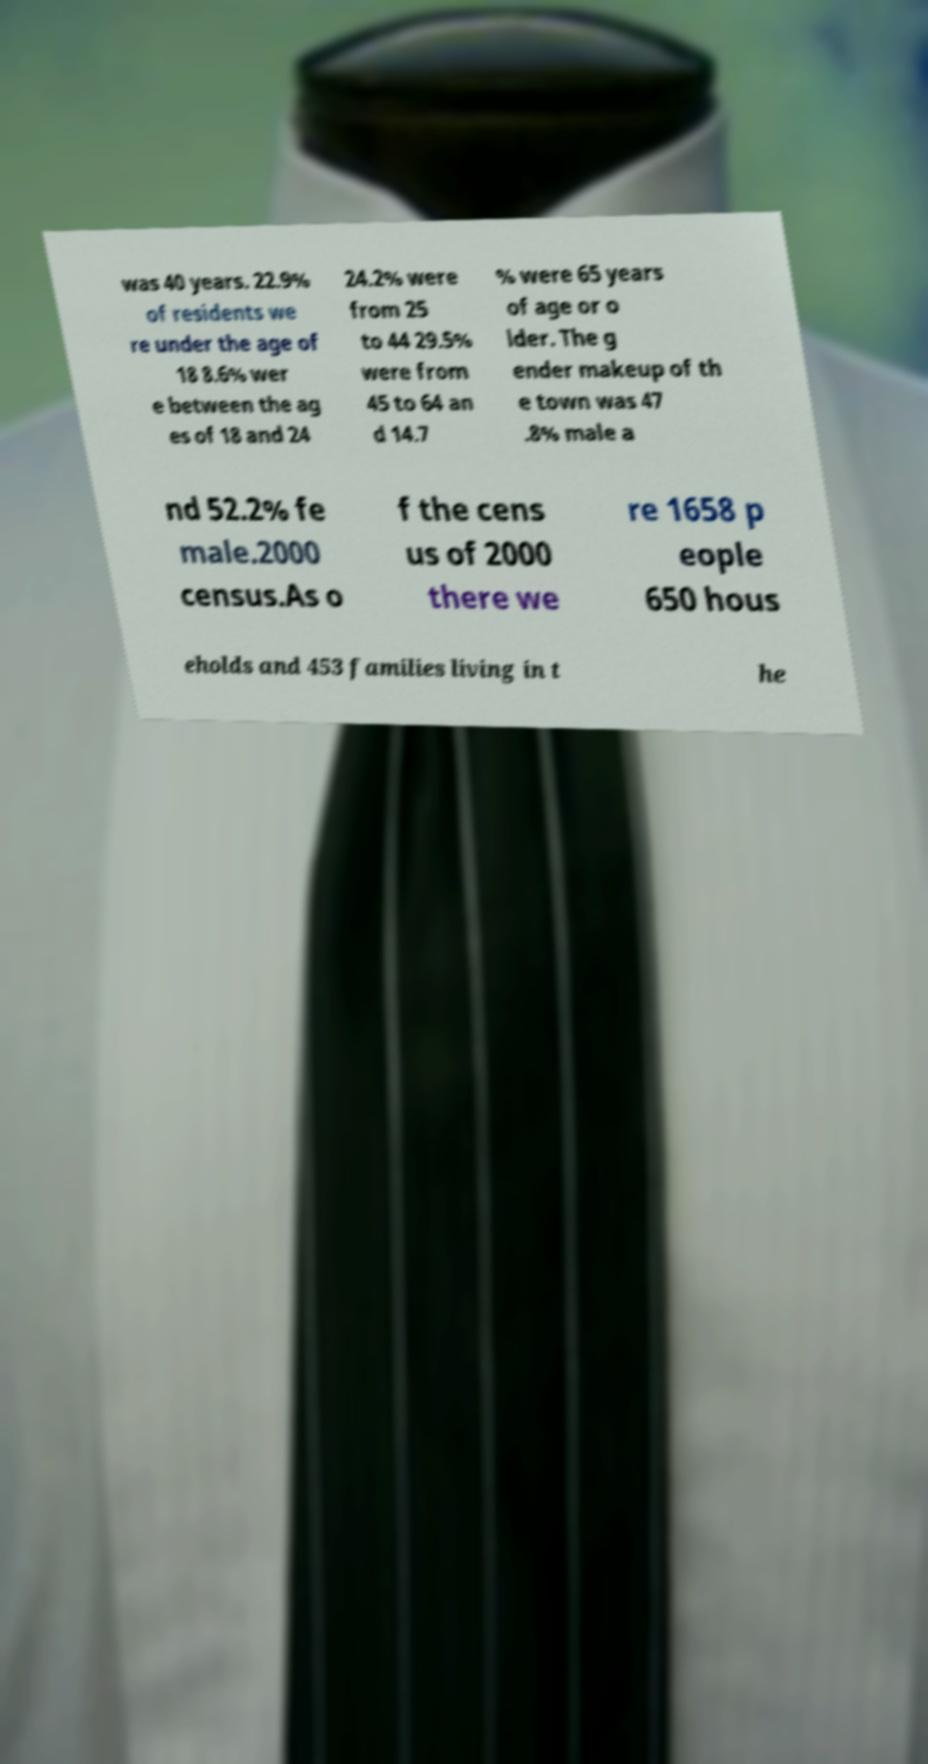What messages or text are displayed in this image? I need them in a readable, typed format. was 40 years. 22.9% of residents we re under the age of 18 8.6% wer e between the ag es of 18 and 24 24.2% were from 25 to 44 29.5% were from 45 to 64 an d 14.7 % were 65 years of age or o lder. The g ender makeup of th e town was 47 .8% male a nd 52.2% fe male.2000 census.As o f the cens us of 2000 there we re 1658 p eople 650 hous eholds and 453 families living in t he 